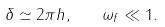<formula> <loc_0><loc_0><loc_500><loc_500>\delta \simeq 2 \pi h , \quad \omega _ { f } \ll 1 .</formula> 